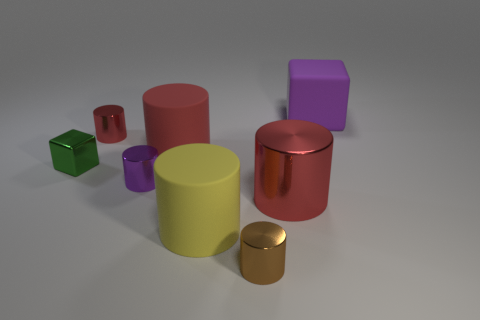What shape is the small object that is behind the purple metallic cylinder and right of the green metallic block?
Provide a succinct answer. Cylinder. There is a purple thing right of the purple thing that is to the left of the big red cylinder behind the green cube; what is its material?
Make the answer very short. Rubber. Is the number of objects behind the shiny cube greater than the number of large red matte objects in front of the yellow cylinder?
Provide a short and direct response. Yes. What number of small purple objects have the same material as the large block?
Your answer should be very brief. 0. There is a tiny shiny object to the right of the red rubber cylinder; does it have the same shape as the object that is behind the tiny red metallic cylinder?
Make the answer very short. No. The large cylinder behind the green block is what color?
Ensure brevity in your answer.  Red. Is there a tiny metallic thing that has the same shape as the yellow rubber object?
Ensure brevity in your answer.  Yes. What material is the small red object?
Keep it short and to the point. Metal. There is a thing that is both on the right side of the brown shiny thing and in front of the red matte cylinder; what is its size?
Offer a terse response. Large. There is a thing that is the same color as the big cube; what material is it?
Ensure brevity in your answer.  Metal. 